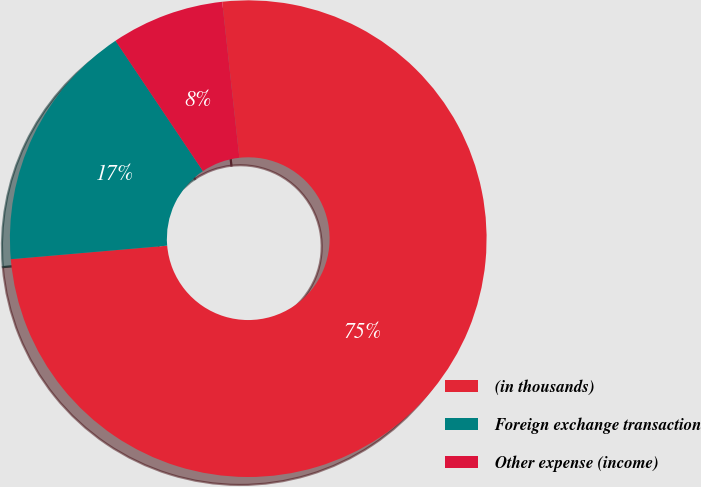<chart> <loc_0><loc_0><loc_500><loc_500><pie_chart><fcel>(in thousands)<fcel>Foreign exchange transaction<fcel>Other expense (income)<nl><fcel>75.37%<fcel>16.97%<fcel>7.66%<nl></chart> 